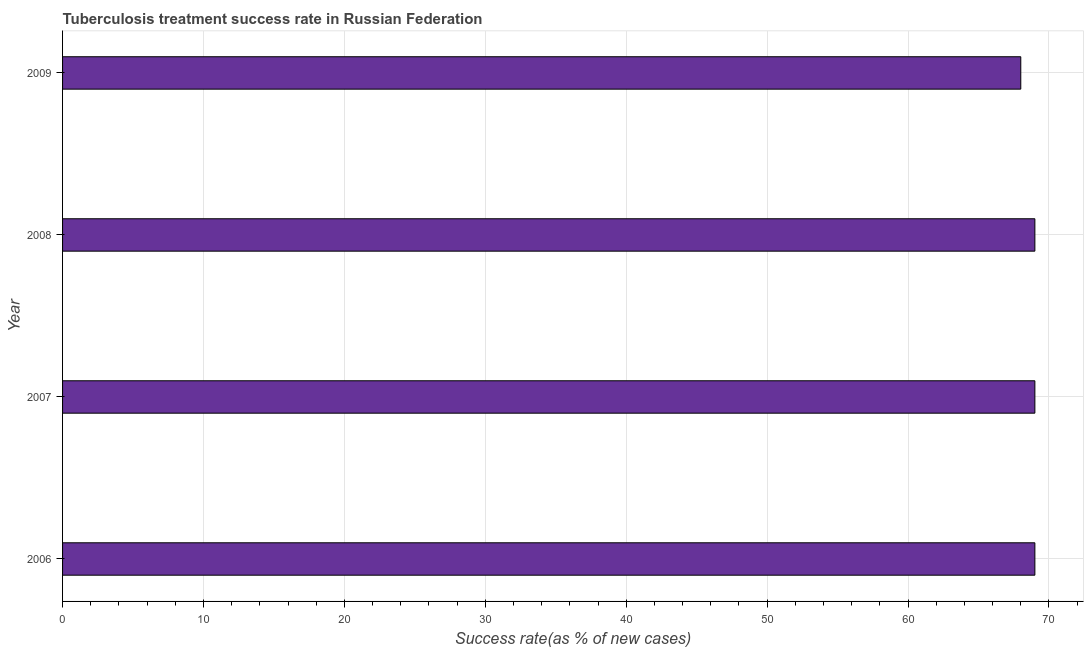What is the title of the graph?
Ensure brevity in your answer.  Tuberculosis treatment success rate in Russian Federation. What is the label or title of the X-axis?
Offer a very short reply. Success rate(as % of new cases). What is the label or title of the Y-axis?
Provide a short and direct response. Year. Across all years, what is the maximum tuberculosis treatment success rate?
Your answer should be compact. 69. In which year was the tuberculosis treatment success rate minimum?
Give a very brief answer. 2009. What is the sum of the tuberculosis treatment success rate?
Your response must be concise. 275. What is the median tuberculosis treatment success rate?
Your response must be concise. 69. In how many years, is the tuberculosis treatment success rate greater than 64 %?
Keep it short and to the point. 4. Do a majority of the years between 2006 and 2007 (inclusive) have tuberculosis treatment success rate greater than 30 %?
Give a very brief answer. Yes. Is the difference between the tuberculosis treatment success rate in 2007 and 2009 greater than the difference between any two years?
Offer a very short reply. Yes. What is the difference between the highest and the second highest tuberculosis treatment success rate?
Make the answer very short. 0. Is the sum of the tuberculosis treatment success rate in 2006 and 2008 greater than the maximum tuberculosis treatment success rate across all years?
Make the answer very short. Yes. What is the difference between the highest and the lowest tuberculosis treatment success rate?
Offer a terse response. 1. Are the values on the major ticks of X-axis written in scientific E-notation?
Your response must be concise. No. What is the Success rate(as % of new cases) of 2006?
Offer a terse response. 69. What is the Success rate(as % of new cases) in 2007?
Your response must be concise. 69. What is the Success rate(as % of new cases) in 2009?
Ensure brevity in your answer.  68. What is the difference between the Success rate(as % of new cases) in 2006 and 2007?
Provide a succinct answer. 0. What is the difference between the Success rate(as % of new cases) in 2006 and 2009?
Your answer should be compact. 1. What is the difference between the Success rate(as % of new cases) in 2007 and 2008?
Provide a succinct answer. 0. What is the difference between the Success rate(as % of new cases) in 2007 and 2009?
Provide a succinct answer. 1. What is the difference between the Success rate(as % of new cases) in 2008 and 2009?
Make the answer very short. 1. What is the ratio of the Success rate(as % of new cases) in 2006 to that in 2008?
Offer a very short reply. 1. What is the ratio of the Success rate(as % of new cases) in 2006 to that in 2009?
Provide a short and direct response. 1.01. What is the ratio of the Success rate(as % of new cases) in 2007 to that in 2009?
Make the answer very short. 1.01. 